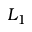<formula> <loc_0><loc_0><loc_500><loc_500>L _ { 1 }</formula> 